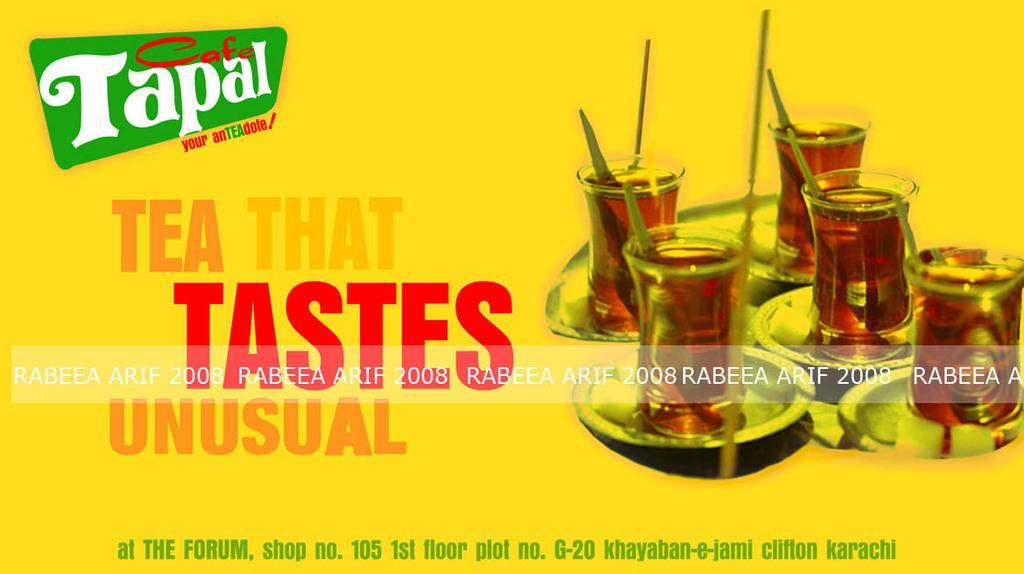Can you describe this image briefly? In this image, we can see yellow poster, on that poster we can see some glasses and some text. 